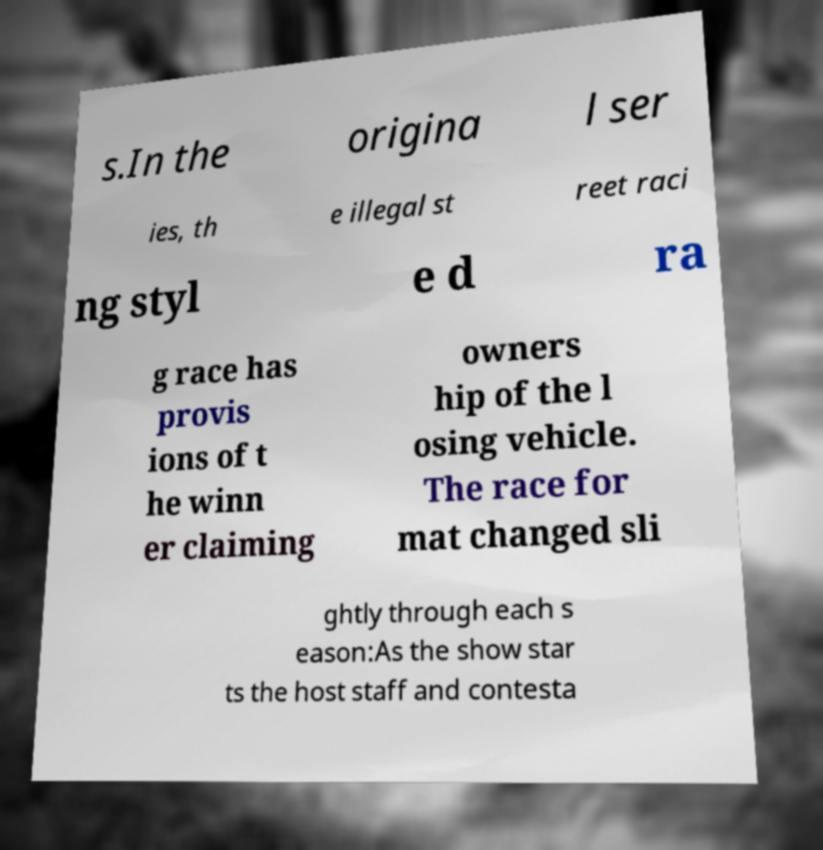What messages or text are displayed in this image? I need them in a readable, typed format. s.In the origina l ser ies, th e illegal st reet raci ng styl e d ra g race has provis ions of t he winn er claiming owners hip of the l osing vehicle. The race for mat changed sli ghtly through each s eason:As the show star ts the host staff and contesta 